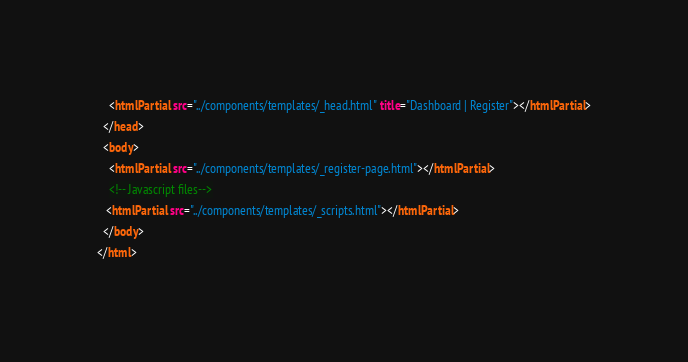Convert code to text. <code><loc_0><loc_0><loc_500><loc_500><_HTML_>    <htmlPartial src="../components/templates/_head.html" title="Dashboard | Register"></htmlPartial>
  </head>
  <body>
    <htmlPartial src="../components/templates/_register-page.html"></htmlPartial>
    <!-- Javascript files-->
   <htmlPartial src="../components/templates/_scripts.html"></htmlPartial>
  </body>
</html></code> 